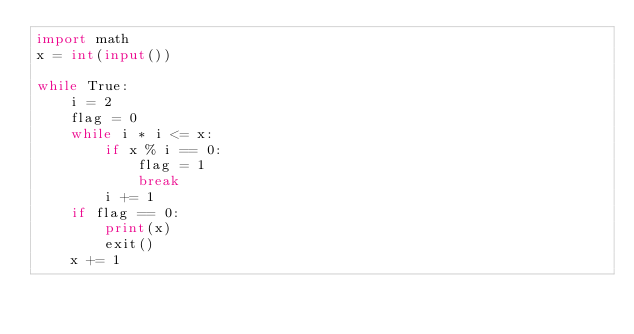Convert code to text. <code><loc_0><loc_0><loc_500><loc_500><_Python_>import math
x = int(input())

while True:
    i = 2
    flag = 0
    while i * i <= x:
        if x % i == 0:
            flag = 1
            break
        i += 1
    if flag == 0:
        print(x)
        exit()
    x += 1
</code> 